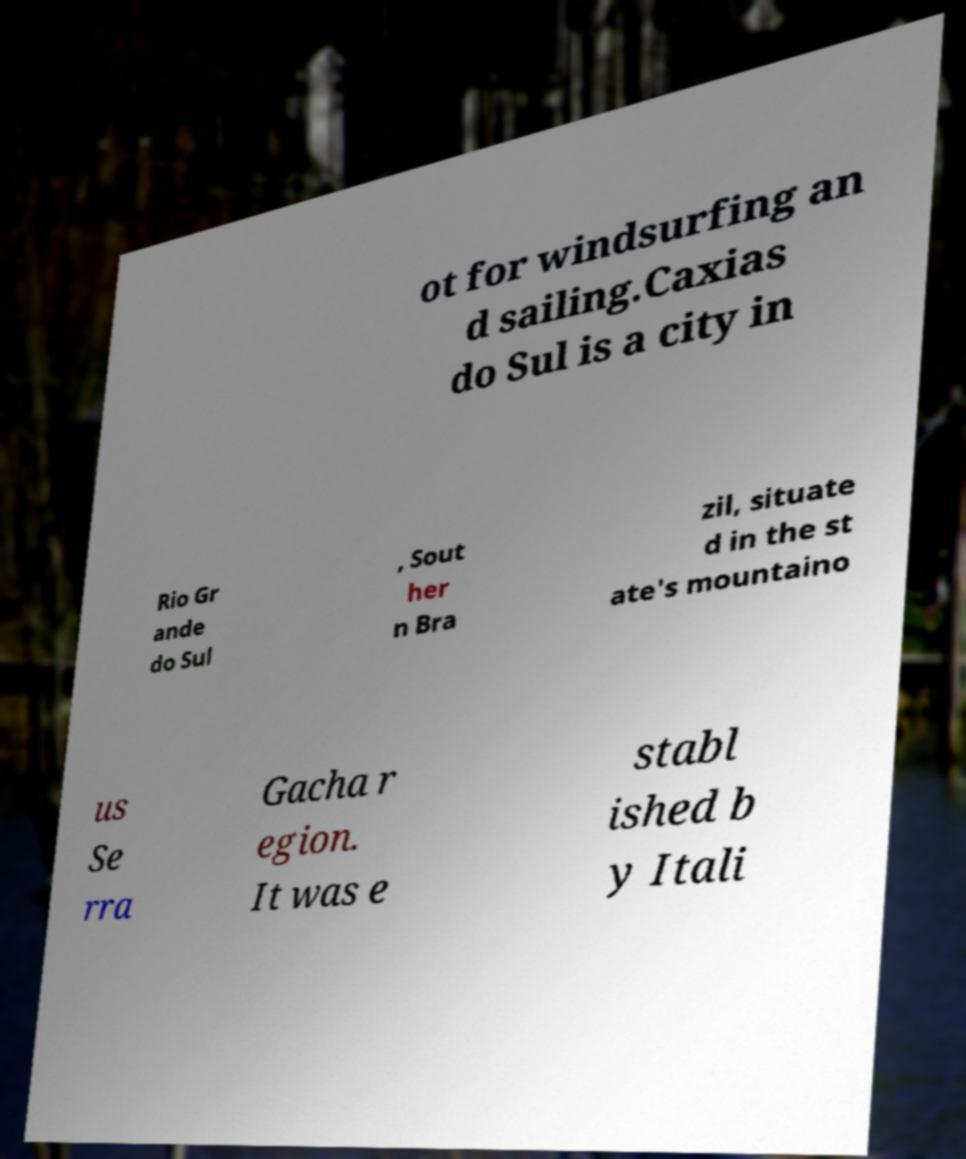Could you extract and type out the text from this image? ot for windsurfing an d sailing.Caxias do Sul is a city in Rio Gr ande do Sul , Sout her n Bra zil, situate d in the st ate's mountaino us Se rra Gacha r egion. It was e stabl ished b y Itali 